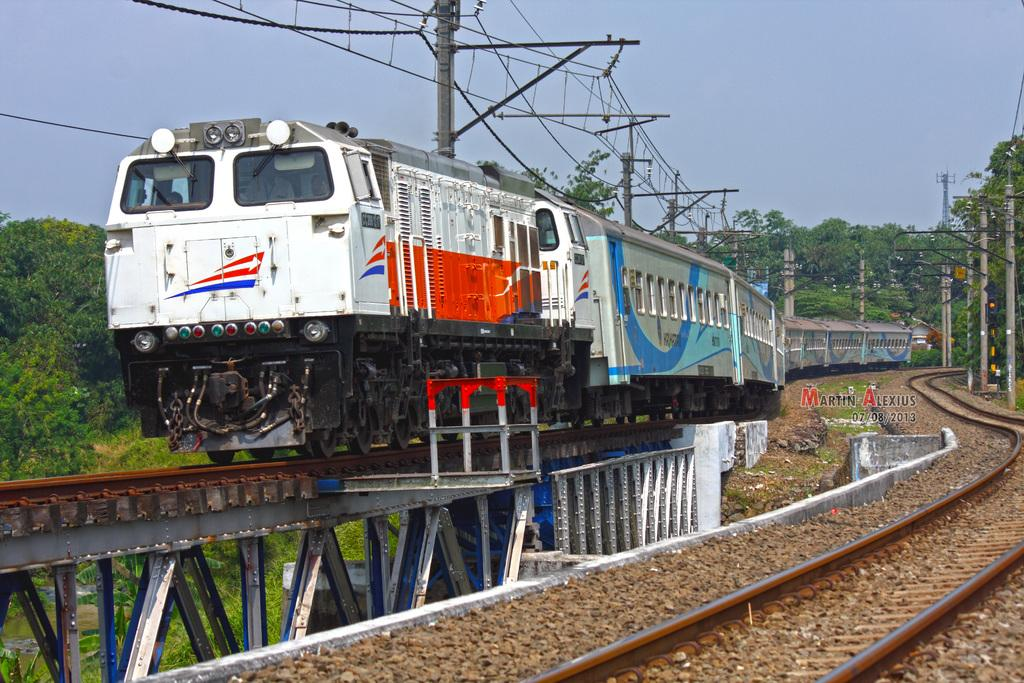What is the main subject of the image? The main subject of the image is a train on a bridge. What can be seen on the right side of the image? There is a railway track on the right side of the image. What is visible in the background of the image? There are current poles, trees, and the sky visible in the background of the image. How many sticks are being used by the birds in the image? There are no birds or sticks present in the image. What type of trip is the train taking in the image? The image does not provide information about the train's destination or purpose, so it cannot be determined from the image. 